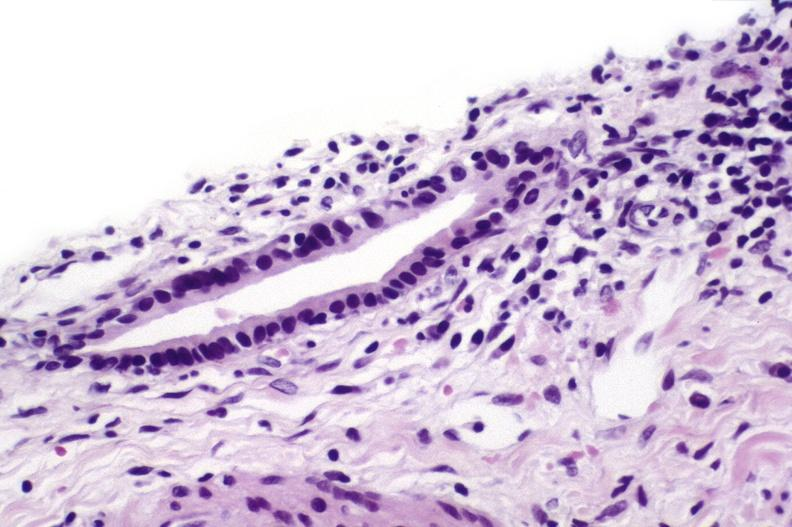s placenta present?
Answer the question using a single word or phrase. No 